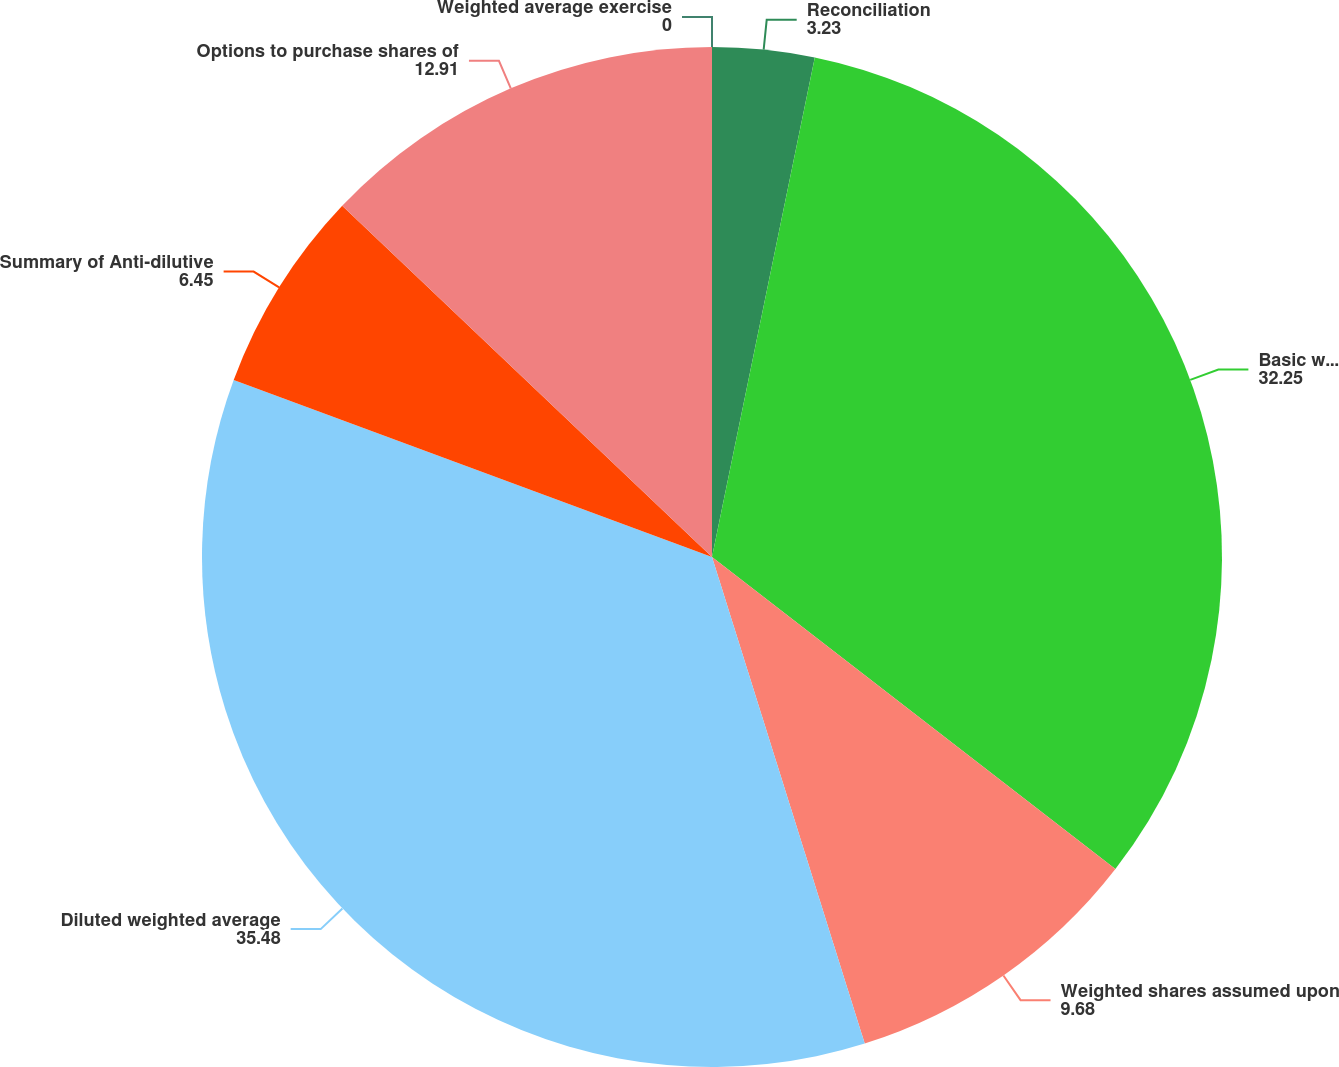<chart> <loc_0><loc_0><loc_500><loc_500><pie_chart><fcel>Reconciliation<fcel>Basic weighted average shares<fcel>Weighted shares assumed upon<fcel>Diluted weighted average<fcel>Summary of Anti-dilutive<fcel>Options to purchase shares of<fcel>Weighted average exercise<nl><fcel>3.23%<fcel>32.25%<fcel>9.68%<fcel>35.48%<fcel>6.45%<fcel>12.91%<fcel>0.0%<nl></chart> 